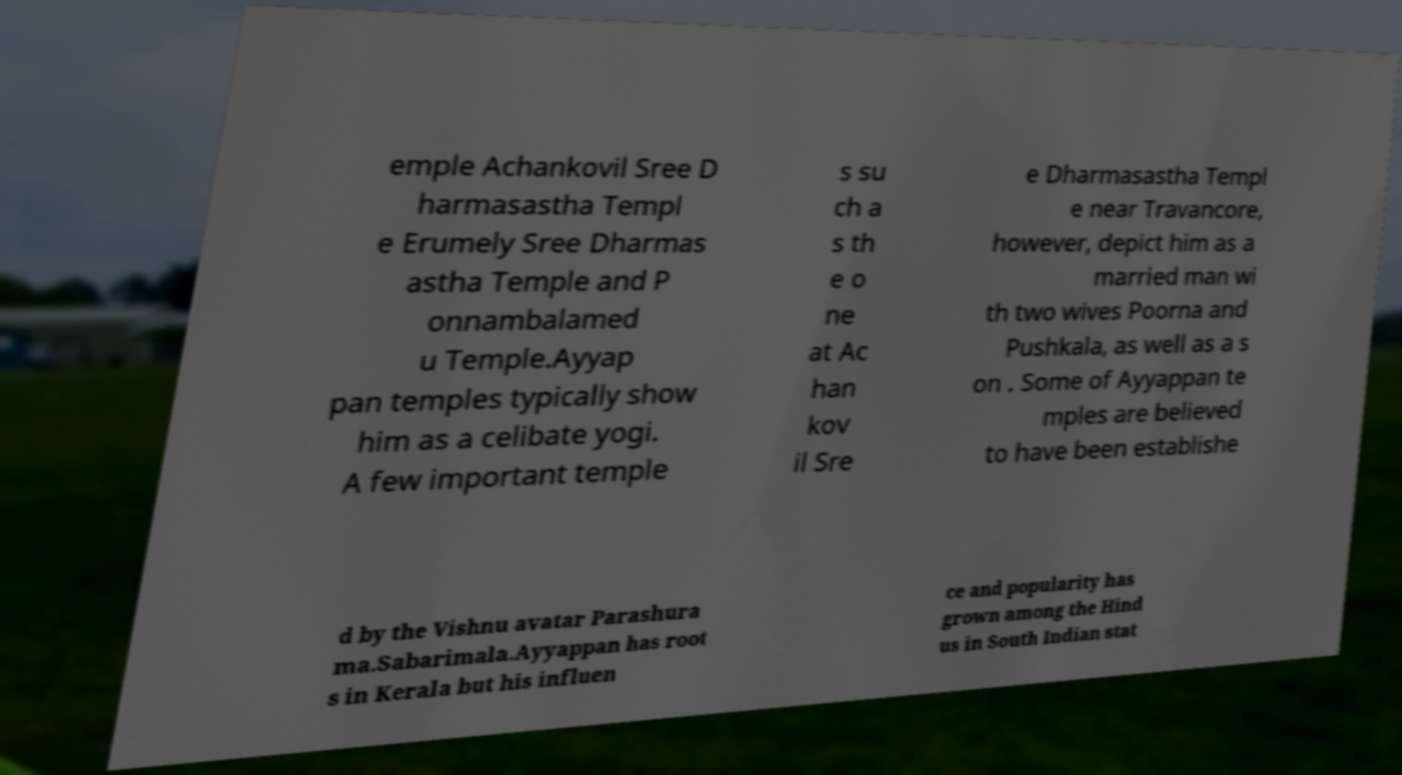There's text embedded in this image that I need extracted. Can you transcribe it verbatim? emple Achankovil Sree D harmasastha Templ e Erumely Sree Dharmas astha Temple and P onnambalamed u Temple.Ayyap pan temples typically show him as a celibate yogi. A few important temple s su ch a s th e o ne at Ac han kov il Sre e Dharmasastha Templ e near Travancore, however, depict him as a married man wi th two wives Poorna and Pushkala, as well as a s on . Some of Ayyappan te mples are believed to have been establishe d by the Vishnu avatar Parashura ma.Sabarimala.Ayyappan has root s in Kerala but his influen ce and popularity has grown among the Hind us in South Indian stat 